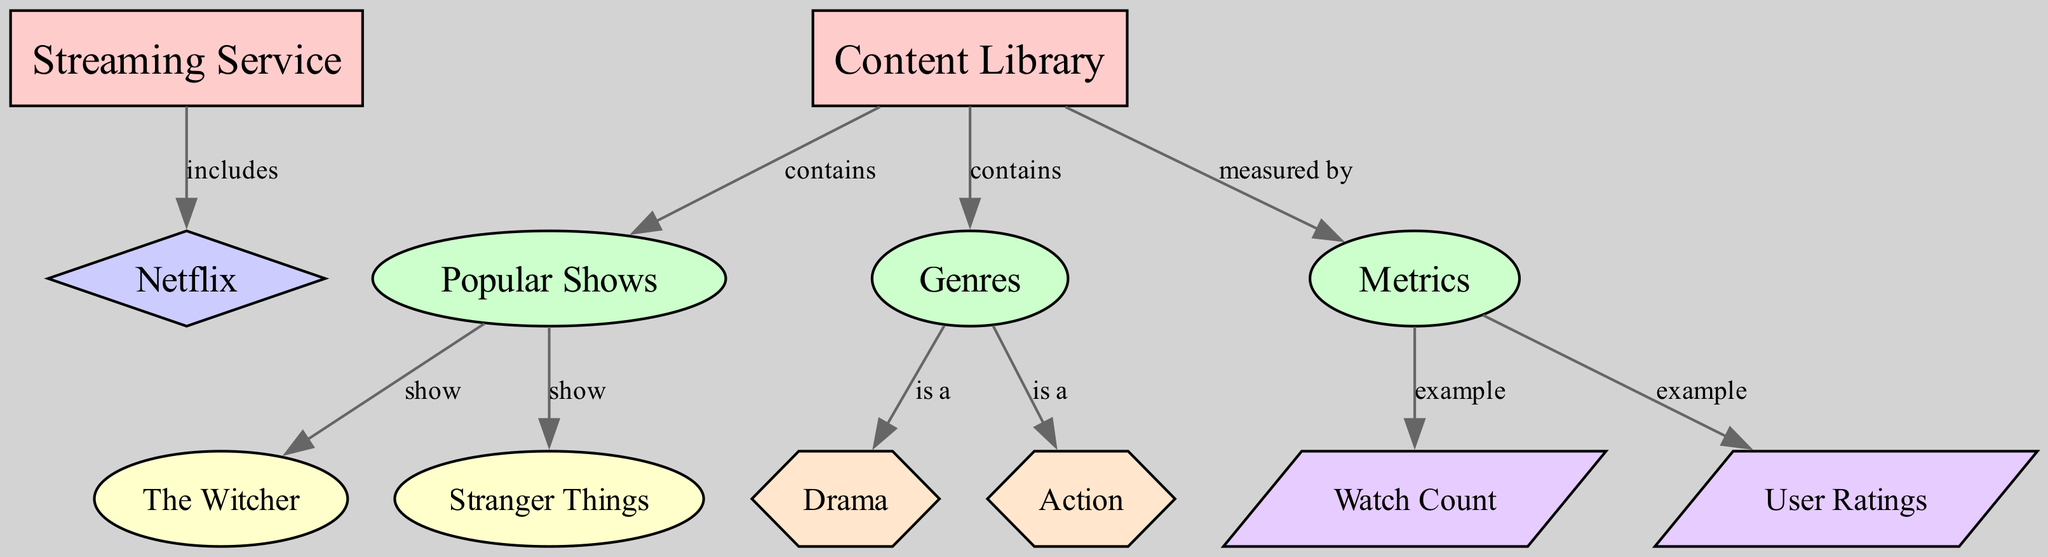What is the streaming service represented in the diagram? The diagram includes a node labeled "Streaming Service," which specifies "Netflix" as the service that it includes.
Answer: Netflix How many shows are categorized as popular in the content library? The "Content Library" node contains two shows labeled under "Popular Shows": "The Witcher" and "Stranger Things," indicating that there are two shows in this category.
Answer: 2 What genre is "The Witcher" classified under? Following the relationships from the "Popular Shows" category to the "Genres" category, "The Witcher" is linked to the "Drama" genre, making this the classification for that show.
Answer: Drama What metric is provided as an example for measuring popularity? The "Metrics" category has two measuring metrics listed as examples: "Watch Count" and "User Ratings." Thus, either of these can answer the question posed.
Answer: Watch Count What type of relationship exists between the "Content Library" and the "Metrics"? The diagram shows that the "Content Library" is measured by the "Metrics," which indicates the type of relationship between these two nodes.
Answer: measured by Which category does "Action" belong to? From the "Genres" category, there's a relationship indicating "Action" is a genre, confirming its classification within the larger category of genres in the content library.
Answer: genre How many edges are there from the "Content Library" node? The "Content Library" node has three outgoing edges to "Popular Shows," "Genres," and "Metrics." Therefore, the total number of edges originating from this node is three.
Answer: 3 What types of nodes are present in the diagram? The diagram features several types of nodes, including "entity," "category," "service," "show," "genre," and "metric." This variety indicates the different classifications of information represented in the diagram.
Answer: entity, category, service, show, genre, metric Which show is associated with the watch count metric? The "Metrics" category lists "Watch Count" as an example metric, but the diagram does not link it specifically to either of the shows, so the transitive association can't apply directly to a show here.
Answer: Not directly linked 